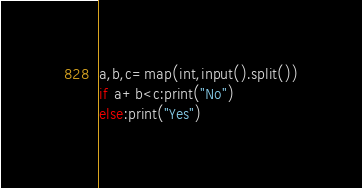Convert code to text. <code><loc_0><loc_0><loc_500><loc_500><_Python_>a,b,c=map(int,input().split())
if a+b<c:print("No")
else:print("Yes")</code> 